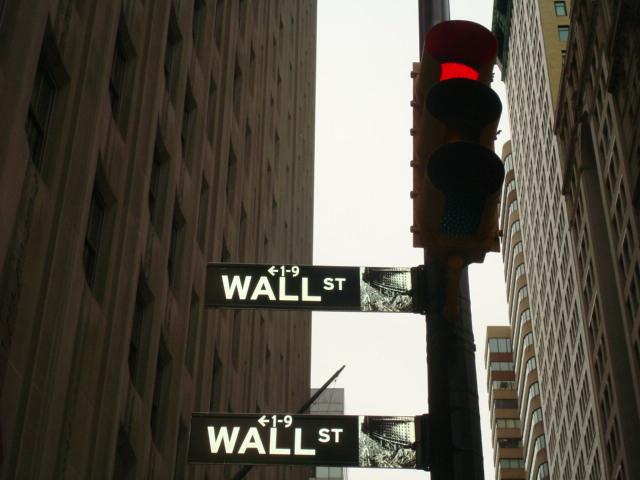What color is the sign?
Give a very brief answer. Black. What street is this?
Keep it brief. Wall st. How many identical signs are there?
Quick response, please. 2. 